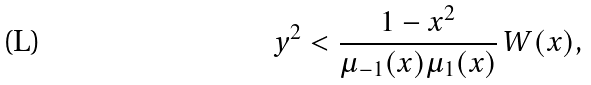Convert formula to latex. <formula><loc_0><loc_0><loc_500><loc_500>y ^ { 2 } < \frac { 1 - x ^ { 2 } } { \mu _ { - 1 } ( x ) \mu _ { 1 } ( x ) } \, W ( x ) ,</formula> 